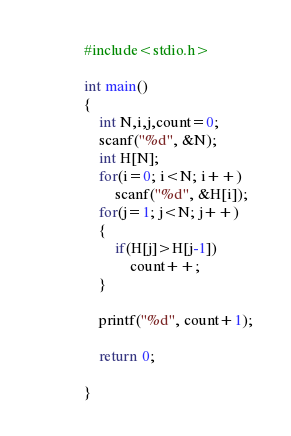<code> <loc_0><loc_0><loc_500><loc_500><_C_>#include<stdio.h>

int main()
{
    int N,i,j,count=0;
    scanf("%d", &N);
    int H[N];
    for(i=0; i<N; i++)
        scanf("%d", &H[i]);
    for(j=1; j<N; j++)
    {
        if(H[j]>H[j-1])
            count++;
    }
    
    printf("%d", count+1);
    
    return 0;
        
}
</code> 